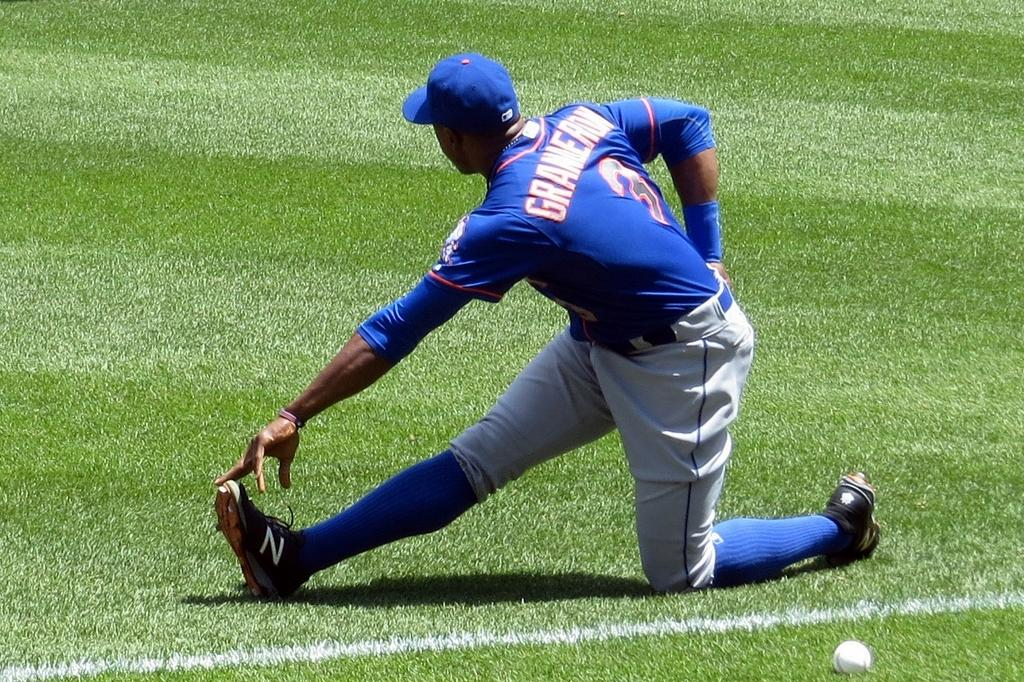Where was the image taken? The image is taken outdoors. What type of surface is visible in the image? There is a ground with grass in the image. What object can be seen on the ground? There is a ball on the ground. What activity is the man in the image engaged in? A man is doing exercise in the image. How many cacti are present in the image? There are no cacti present in the image. Can you see a swing in the image? There is no swing present in the image. 